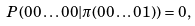<formula> <loc_0><loc_0><loc_500><loc_500>P ( 0 0 \dots 0 0 & | \pi ( 0 0 \dots 0 1 ) ) = 0 ,</formula> 